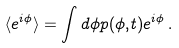<formula> <loc_0><loc_0><loc_500><loc_500>\langle e ^ { i \phi } \rangle = \int d \phi p ( \phi , t ) e ^ { i \phi } \, .</formula> 